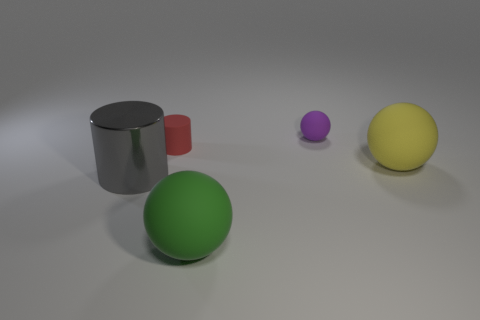What color is the small matte object on the right side of the small thing on the left side of the matte ball in front of the large yellow rubber ball?
Offer a terse response. Purple. What color is the big shiny thing?
Give a very brief answer. Gray. Is the number of green objects that are in front of the large gray cylinder greater than the number of large green matte things that are to the right of the purple ball?
Make the answer very short. Yes. Do the large yellow object and the large thing that is to the left of the small red object have the same shape?
Provide a succinct answer. No. Do the ball that is in front of the gray metal object and the cylinder on the left side of the red matte cylinder have the same size?
Keep it short and to the point. Yes. Are there any balls in front of the big rubber thing that is left of the tiny rubber thing that is on the right side of the large green sphere?
Your response must be concise. No. Are there fewer large gray cylinders behind the small sphere than metal objects to the left of the big yellow thing?
Provide a succinct answer. Yes. What is the shape of the red thing that is made of the same material as the green object?
Offer a very short reply. Cylinder. There is a cylinder that is in front of the ball that is right of the tiny thing that is right of the tiny red matte cylinder; what is its size?
Your answer should be compact. Large. Is the number of big green matte balls greater than the number of large brown things?
Make the answer very short. Yes. 